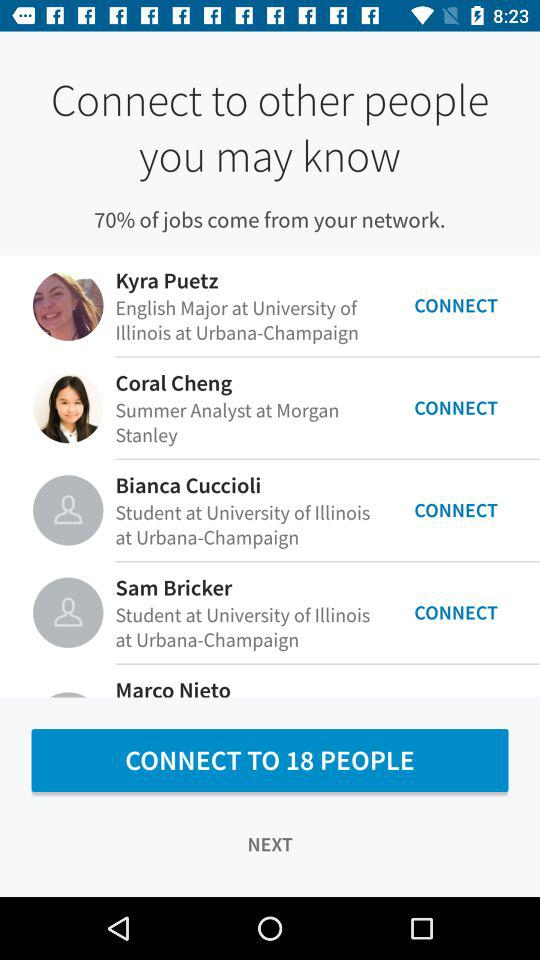Who is the analyst at Morgan? The analyst at Morgan is Coral Cheng. 